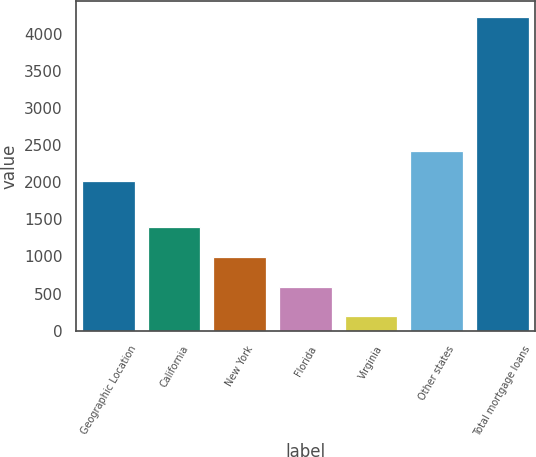<chart> <loc_0><loc_0><loc_500><loc_500><bar_chart><fcel>Geographic Location<fcel>California<fcel>New York<fcel>Florida<fcel>Virginia<fcel>Other states<fcel>Total mortgage loans<nl><fcel>2012<fcel>1401.49<fcel>998.36<fcel>595.23<fcel>192.1<fcel>2415.13<fcel>4223.4<nl></chart> 